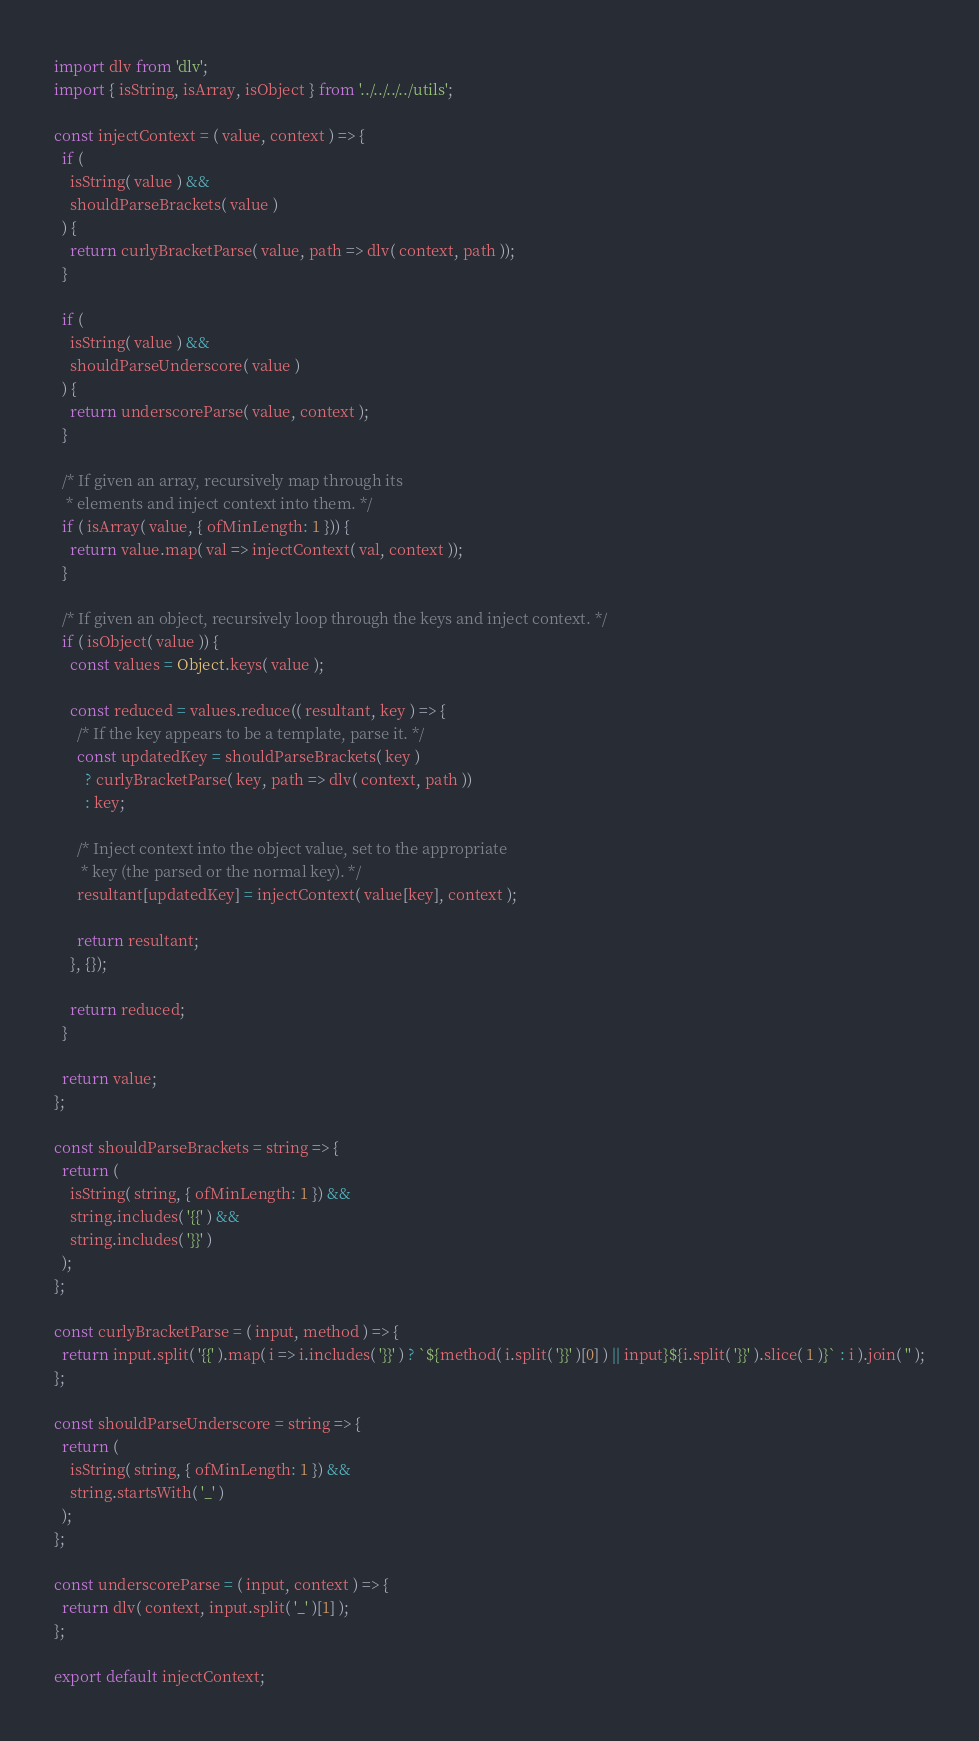Convert code to text. <code><loc_0><loc_0><loc_500><loc_500><_JavaScript_>import dlv from 'dlv';
import { isString, isArray, isObject } from '../../../../utils';

const injectContext = ( value, context ) => {
  if (
    isString( value ) &&
    shouldParseBrackets( value )
  ) {
    return curlyBracketParse( value, path => dlv( context, path ));
  }

  if (
    isString( value ) &&
    shouldParseUnderscore( value )
  ) {
    return underscoreParse( value, context );
  }

  /* If given an array, recursively map through its
   * elements and inject context into them. */
  if ( isArray( value, { ofMinLength: 1 })) {
    return value.map( val => injectContext( val, context ));
  }

  /* If given an object, recursively loop through the keys and inject context. */
  if ( isObject( value )) {
    const values = Object.keys( value );

    const reduced = values.reduce(( resultant, key ) => {
      /* If the key appears to be a template, parse it. */
      const updatedKey = shouldParseBrackets( key )
        ? curlyBracketParse( key, path => dlv( context, path ))
        : key;

      /* Inject context into the object value, set to the appropriate
       * key (the parsed or the normal key). */
      resultant[updatedKey] = injectContext( value[key], context );

      return resultant;
    }, {});

    return reduced;
  }

  return value;
};

const shouldParseBrackets = string => {
  return (
    isString( string, { ofMinLength: 1 }) &&
    string.includes( '{{' ) &&
    string.includes( '}}' )
  );
};

const curlyBracketParse = ( input, method ) => {
  return input.split( '{{' ).map( i => i.includes( '}}' ) ? `${method( i.split( '}}' )[0] ) || input}${i.split( '}}' ).slice( 1 )}` : i ).join( '' );
};

const shouldParseUnderscore = string => {
  return (
    isString( string, { ofMinLength: 1 }) &&
    string.startsWith( '_' )
  );
};

const underscoreParse = ( input, context ) => {
  return dlv( context, input.split( '_' )[1] );
};

export default injectContext;
</code> 